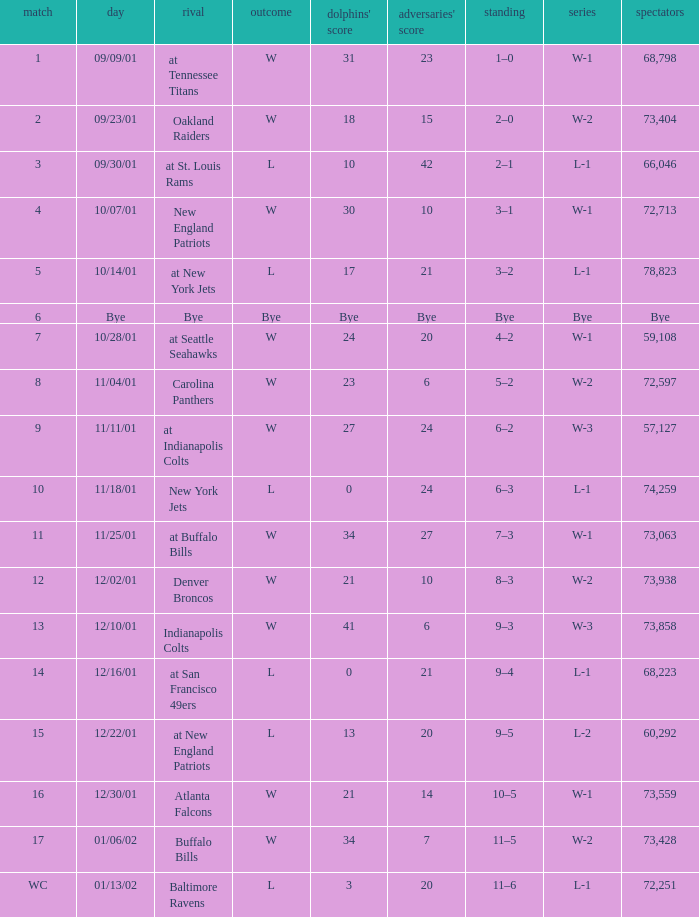How many attended the game with an opponent of bye? Bye. 